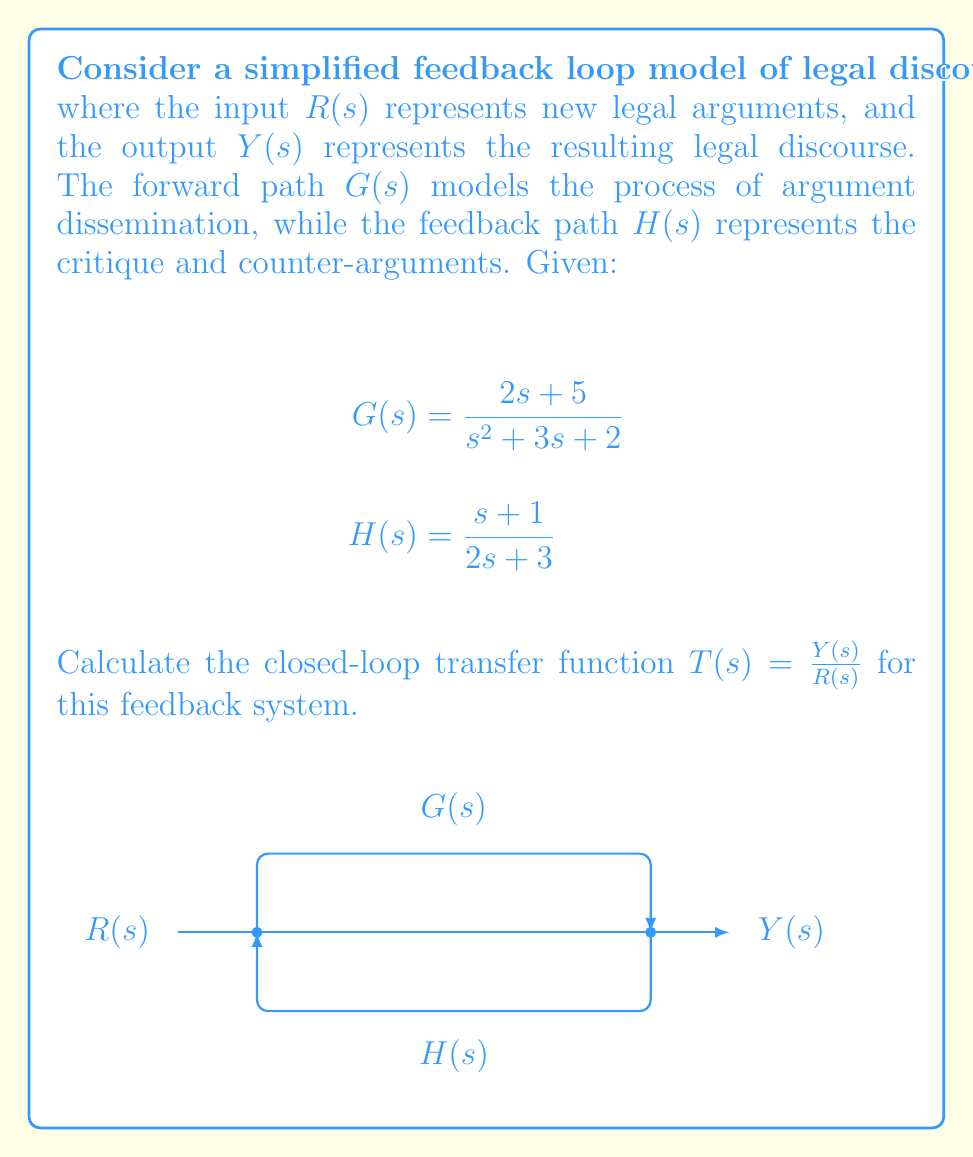Teach me how to tackle this problem. To calculate the closed-loop transfer function, we'll follow these steps:

1) The general form of a closed-loop transfer function for a negative feedback system is:

   $$T(s) = \frac{G(s)}{1 + G(s)H(s)}$$

2) We need to substitute the given $G(s)$ and $H(s)$ into this equation:

   $$T(s) = \frac{\frac{2s + 5}{s^2 + 3s + 2}}{1 + \frac{2s + 5}{s^2 + 3s + 2} \cdot \frac{s + 1}{2s + 3}}$$

3) To simplify this, let's first multiply the numerator and denominator by $(s^2 + 3s + 2)(2s + 3)$:

   $$T(s) = \frac{(2s + 5)(2s + 3)}{(s^2 + 3s + 2)(2s + 3) + (2s + 5)(s + 1)}$$

4) Expand the numerator:
   $(2s + 5)(2s + 3) = 4s^2 + 6s + 10s + 15 = 4s^2 + 16s + 15$

5) Expand the denominator:
   $(s^2 + 3s + 2)(2s + 3) + (2s + 5)(s + 1)$
   $= (2s^3 + 3s^2 + 6s^2 + 9s + 4s + 6) + (2s^2 + 2s + 5s + 5)$
   $= 2s^3 + 11s^2 + 20s + 11$

6) Therefore, the closed-loop transfer function is:

   $$T(s) = \frac{4s^2 + 16s + 15}{2s^3 + 11s^2 + 20s + 11}$$

This transfer function models how new legal arguments (input) are transformed into resulting legal discourse (output) in this simplified feedback system.
Answer: $$T(s) = \frac{4s^2 + 16s + 15}{2s^3 + 11s^2 + 20s + 11}$$ 